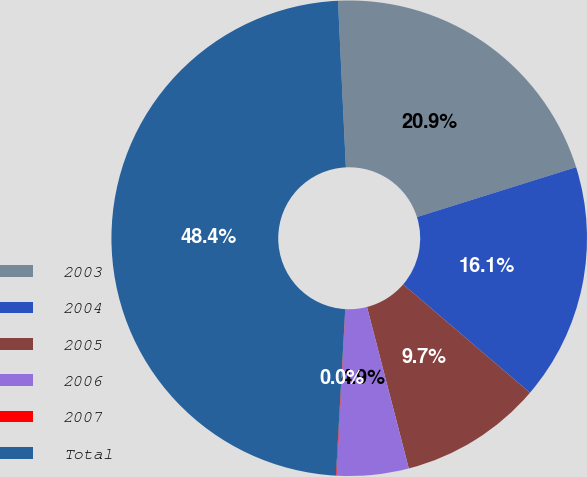<chart> <loc_0><loc_0><loc_500><loc_500><pie_chart><fcel>2003<fcel>2004<fcel>2005<fcel>2006<fcel>2007<fcel>Total<nl><fcel>20.92%<fcel>16.09%<fcel>9.71%<fcel>4.88%<fcel>0.04%<fcel>48.36%<nl></chart> 